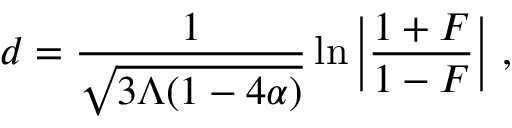Convert formula to latex. <formula><loc_0><loc_0><loc_500><loc_500>d = \frac { 1 } { \sqrt { 3 \Lambda ( 1 - 4 \alpha ) } } \ln { \left | \frac { 1 + F } { 1 - F } \right | } ,</formula> 